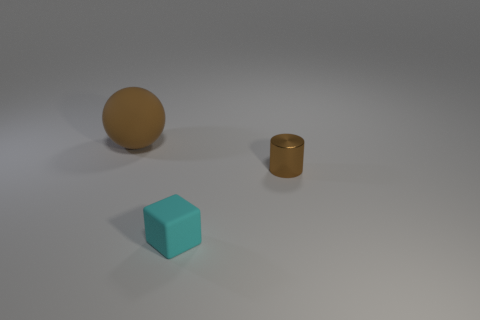Add 3 brown rubber things. How many objects exist? 6 Subtract all blocks. How many objects are left? 2 Subtract 0 cyan spheres. How many objects are left? 3 Subtract all large blue metallic balls. Subtract all cyan matte things. How many objects are left? 2 Add 2 brown balls. How many brown balls are left? 3 Add 1 tiny gray cubes. How many tiny gray cubes exist? 1 